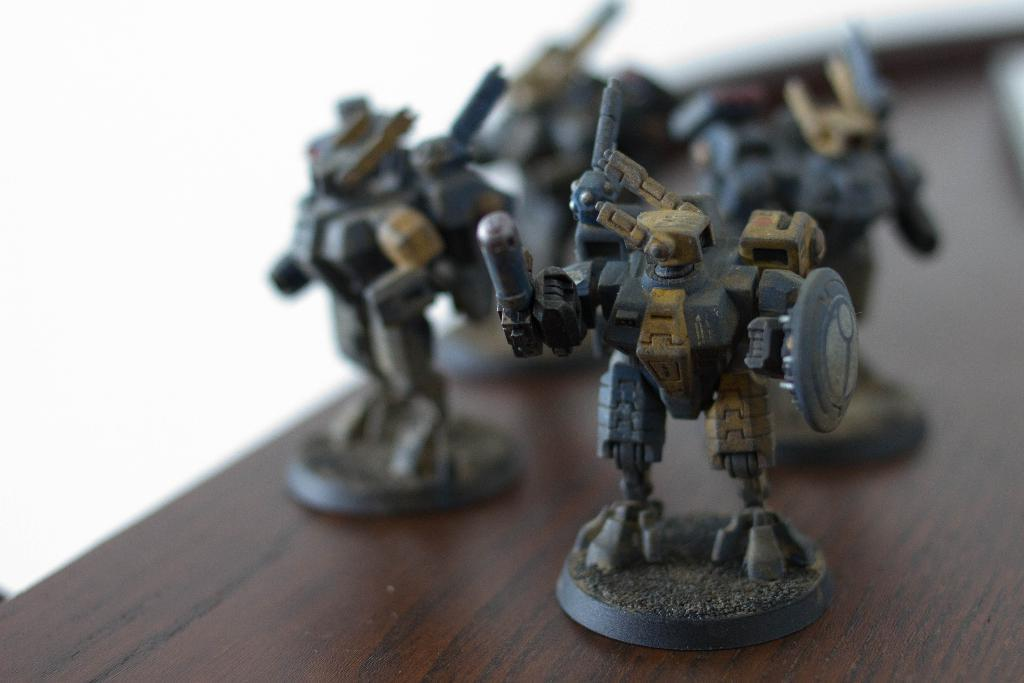What objects are on the wooden table in the image? There are toys on a wooden table in the image. What can be seen in the background of the image? The background is white in color. Is there a cannon being used by a laborer in the image? No, there is no cannon or laborer present in the image. Are there any cobwebs visible in the image? No, there are no cobwebs visible in the image. 